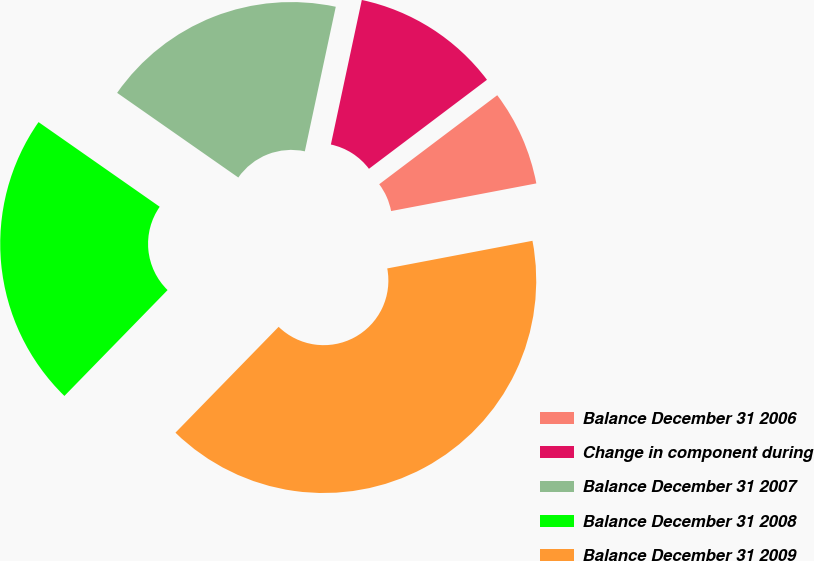Convert chart to OTSL. <chart><loc_0><loc_0><loc_500><loc_500><pie_chart><fcel>Balance December 31 2006<fcel>Change in component during<fcel>Balance December 31 2007<fcel>Balance December 31 2008<fcel>Balance December 31 2009<nl><fcel>7.29%<fcel>11.36%<fcel>18.65%<fcel>22.41%<fcel>40.29%<nl></chart> 